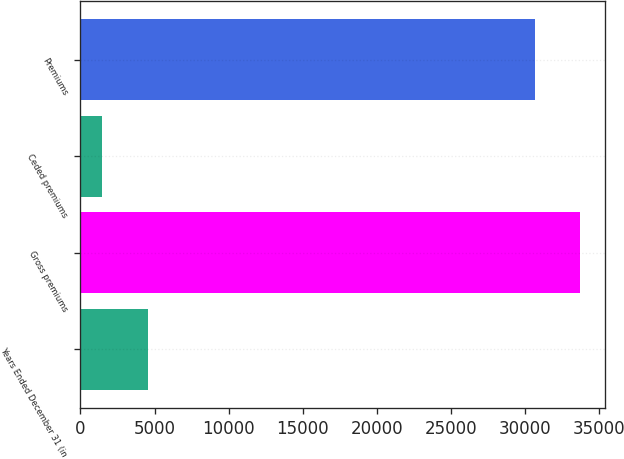Convert chart. <chart><loc_0><loc_0><loc_500><loc_500><bar_chart><fcel>Years Ended December 31 (in<fcel>Gross premiums<fcel>Ceded premiums<fcel>Premiums<nl><fcel>4544.6<fcel>33699.6<fcel>1481<fcel>30636<nl></chart> 